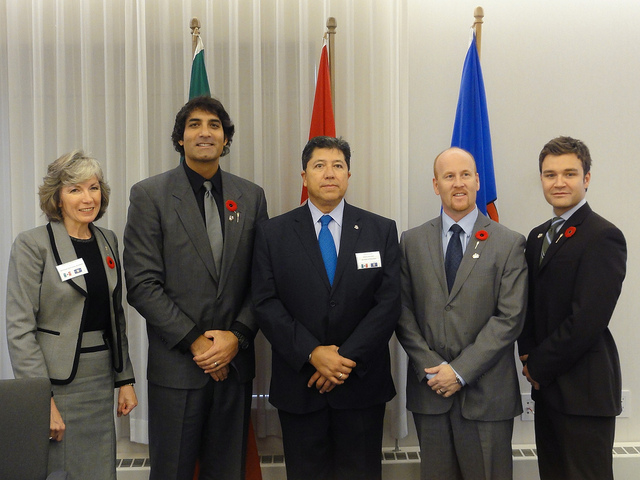<image>Why is the guy to the left taller? It is unanswerable why the guy to the left is taller. The reasons could be genetics or personal physical factors. Why is the guy to the left taller? I don't know why the guy to the left is taller. It can be because of good genes, genetics, or any other reason. 